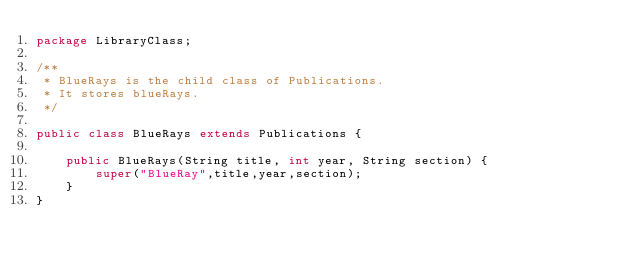Convert code to text. <code><loc_0><loc_0><loc_500><loc_500><_Java_>package LibraryClass;

/**
 * BlueRays is the child class of Publications.
 * It stores blueRays.
 */

public class BlueRays extends Publications {

    public BlueRays(String title, int year, String section) {
        super("BlueRay",title,year,section);
    }
}</code> 